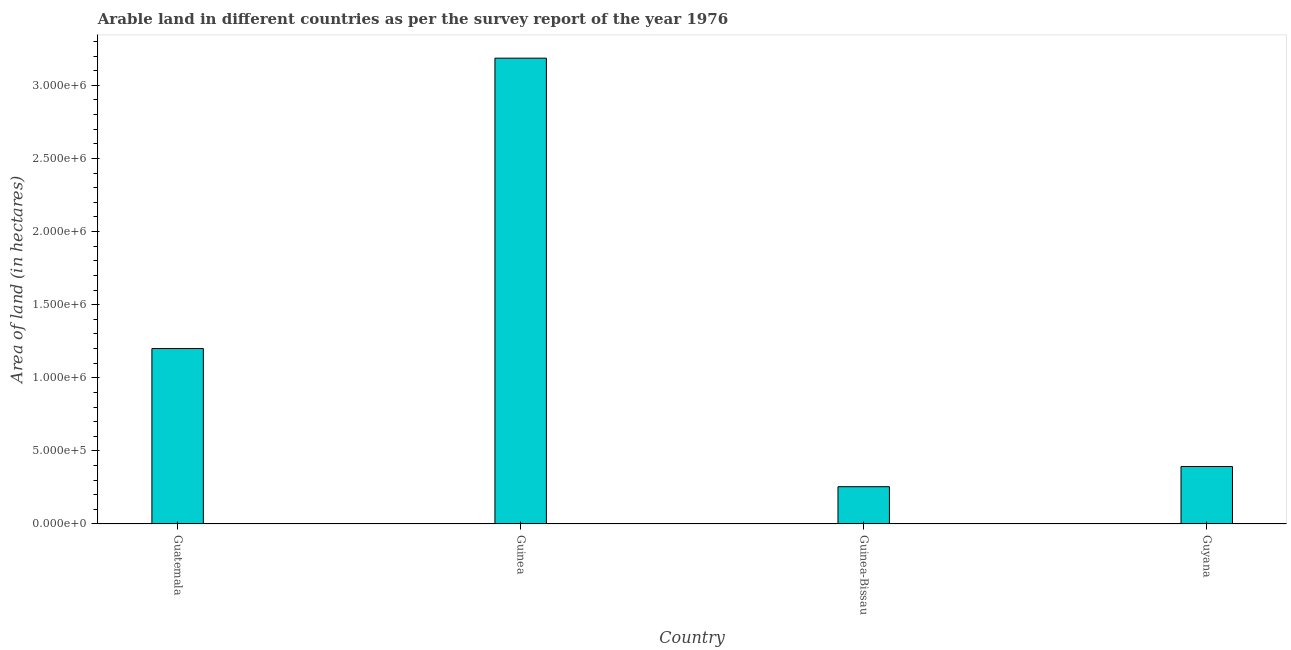Does the graph contain any zero values?
Ensure brevity in your answer.  No. What is the title of the graph?
Provide a short and direct response. Arable land in different countries as per the survey report of the year 1976. What is the label or title of the X-axis?
Keep it short and to the point. Country. What is the label or title of the Y-axis?
Keep it short and to the point. Area of land (in hectares). What is the area of land in Guinea-Bissau?
Your answer should be compact. 2.55e+05. Across all countries, what is the maximum area of land?
Your response must be concise. 3.19e+06. Across all countries, what is the minimum area of land?
Your response must be concise. 2.55e+05. In which country was the area of land maximum?
Your answer should be compact. Guinea. In which country was the area of land minimum?
Keep it short and to the point. Guinea-Bissau. What is the sum of the area of land?
Give a very brief answer. 5.03e+06. What is the difference between the area of land in Guinea and Guyana?
Offer a terse response. 2.79e+06. What is the average area of land per country?
Your response must be concise. 1.26e+06. What is the median area of land?
Offer a very short reply. 7.96e+05. In how many countries, is the area of land greater than 800000 hectares?
Your answer should be very brief. 2. What is the ratio of the area of land in Guatemala to that in Guyana?
Offer a terse response. 3.05. What is the difference between the highest and the second highest area of land?
Your answer should be very brief. 1.99e+06. What is the difference between the highest and the lowest area of land?
Give a very brief answer. 2.93e+06. What is the Area of land (in hectares) of Guatemala?
Offer a very short reply. 1.20e+06. What is the Area of land (in hectares) in Guinea?
Offer a very short reply. 3.19e+06. What is the Area of land (in hectares) of Guinea-Bissau?
Keep it short and to the point. 2.55e+05. What is the Area of land (in hectares) in Guyana?
Your answer should be very brief. 3.93e+05. What is the difference between the Area of land (in hectares) in Guatemala and Guinea?
Your answer should be very brief. -1.99e+06. What is the difference between the Area of land (in hectares) in Guatemala and Guinea-Bissau?
Make the answer very short. 9.45e+05. What is the difference between the Area of land (in hectares) in Guatemala and Guyana?
Your answer should be compact. 8.07e+05. What is the difference between the Area of land (in hectares) in Guinea and Guinea-Bissau?
Offer a terse response. 2.93e+06. What is the difference between the Area of land (in hectares) in Guinea and Guyana?
Ensure brevity in your answer.  2.79e+06. What is the difference between the Area of land (in hectares) in Guinea-Bissau and Guyana?
Your answer should be compact. -1.38e+05. What is the ratio of the Area of land (in hectares) in Guatemala to that in Guinea?
Your response must be concise. 0.38. What is the ratio of the Area of land (in hectares) in Guatemala to that in Guinea-Bissau?
Offer a terse response. 4.71. What is the ratio of the Area of land (in hectares) in Guatemala to that in Guyana?
Your answer should be very brief. 3.05. What is the ratio of the Area of land (in hectares) in Guinea to that in Guinea-Bissau?
Ensure brevity in your answer.  12.49. What is the ratio of the Area of land (in hectares) in Guinea to that in Guyana?
Provide a succinct answer. 8.11. What is the ratio of the Area of land (in hectares) in Guinea-Bissau to that in Guyana?
Ensure brevity in your answer.  0.65. 